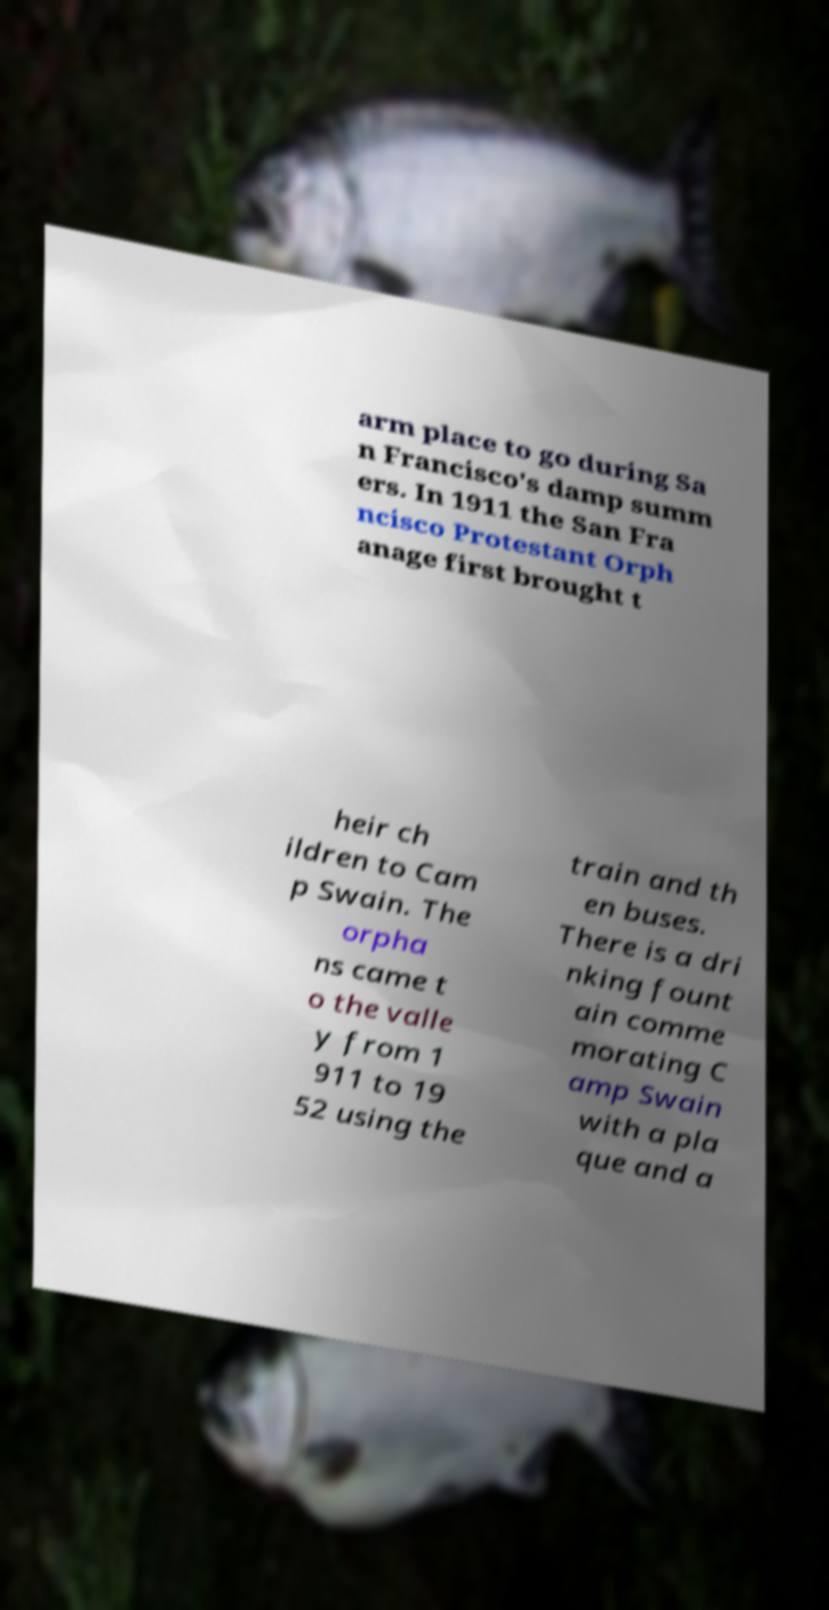There's text embedded in this image that I need extracted. Can you transcribe it verbatim? arm place to go during Sa n Francisco's damp summ ers. In 1911 the San Fra ncisco Protestant Orph anage first brought t heir ch ildren to Cam p Swain. The orpha ns came t o the valle y from 1 911 to 19 52 using the train and th en buses. There is a dri nking fount ain comme morating C amp Swain with a pla que and a 